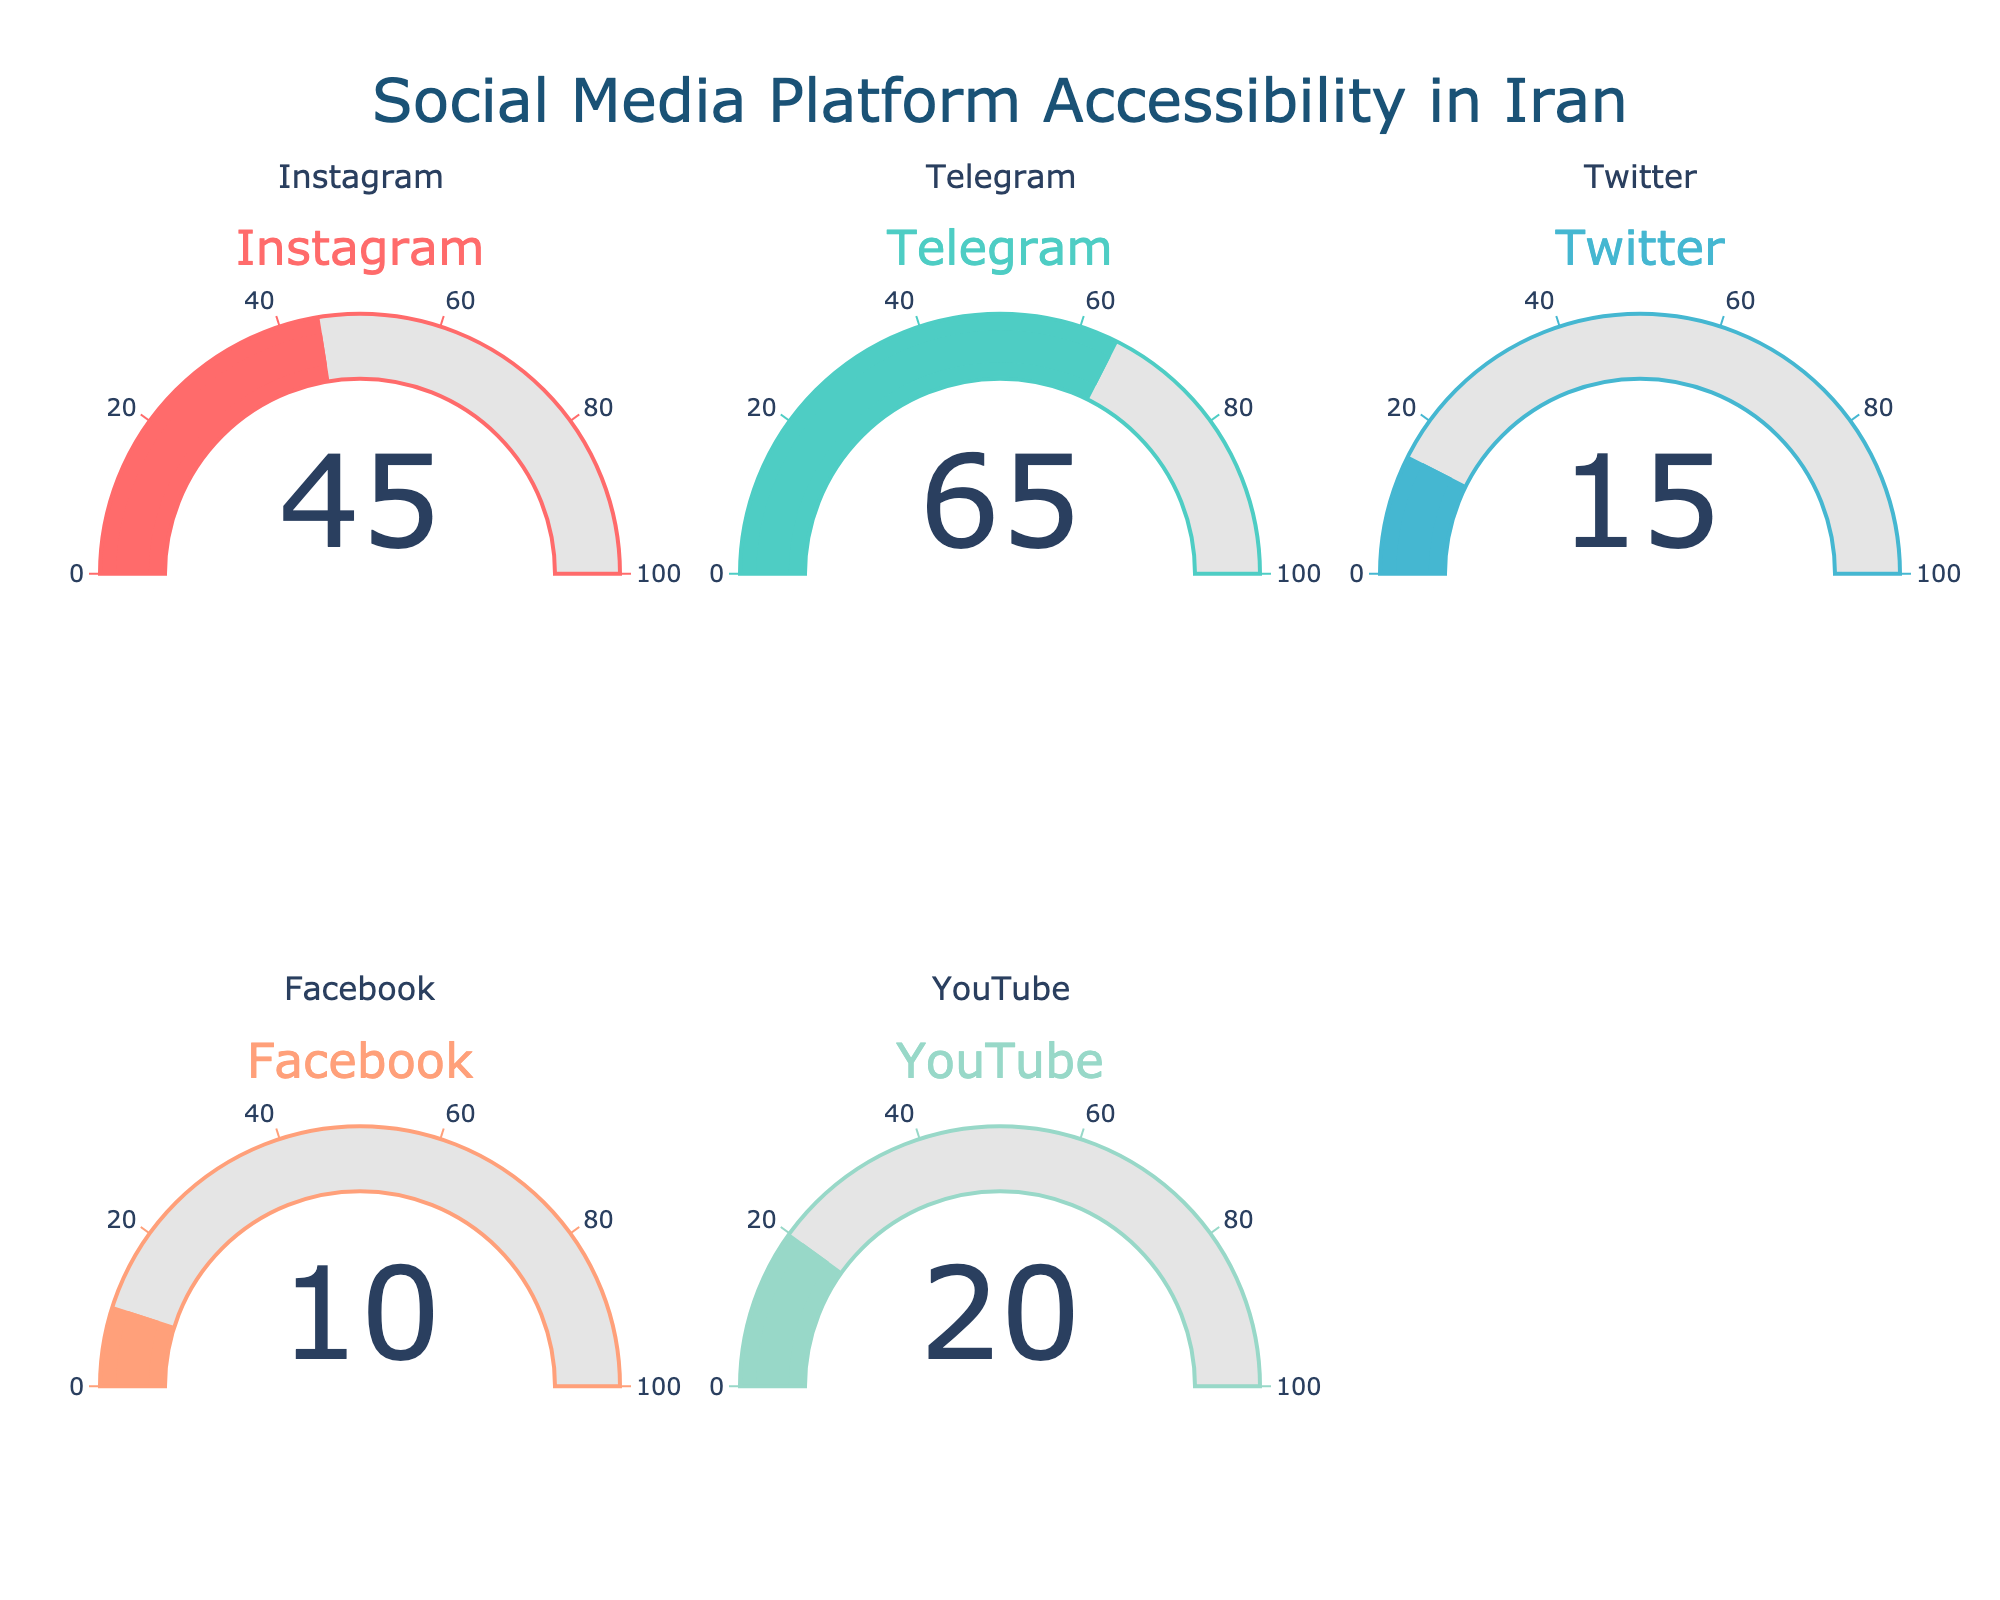What is the accessibility rate for Instagram? The accessibility rate for Instagram is displayed on its gauge, which shows a value of 45.
Answer: 45 Which social media platform has the lowest accessibility rate? By looking at the values on the gauges, Facebook has the lowest accessibility rate, displayed as 10.
Answer: Facebook What is the difference in accessibility rates between Telegram and Twitter? The accessibility rate for Telegram is 65, and for Twitter, it is 15. The difference between these two rates is 65 - 15 = 50.
Answer: 50 How many platforms have an accessibility rate above 20? By checking the accessibility rates displayed on the gauges, only Instagram (45) and Telegram (65) are above 20. Therefore, there are 2 platforms.
Answer: 2 Which platform shows the highest accessibility rate, and what is the value? By examining all gauges, Telegram shows the highest rate, which is 65.
Answer: Telegram, 65 What is the average accessibility rate across all platforms? The accessibility rates are 45 (Instagram), 65 (Telegram), 15 (Twitter), 10 (Facebook), and 20 (YouTube). Adding these gives 45 + 65 + 15 + 10 + 20 = 155. Dividing by the number of platforms (5) gives 155 / 5 = 31.
Answer: 31 Which platform has a lower accessibility rate, YouTube or Instagram? By comparing the values shown on the gauges, YouTube has a rate of 20, and Instagram has a rate of 45. Therefore, YouTube has a lower rate.
Answer: YouTube What is the total sum of the accessibility rates for Facebook and Twitter? The accessibility rate for Facebook is 10 and for Twitter is 15. Adding these gives 10 + 15 = 25.
Answer: 25 Are there any platforms with an accessibility rate exactly equal to 20? By looking at the gauges, YouTube has an accessibility rate of 20.
Answer: Yes, YouTube 